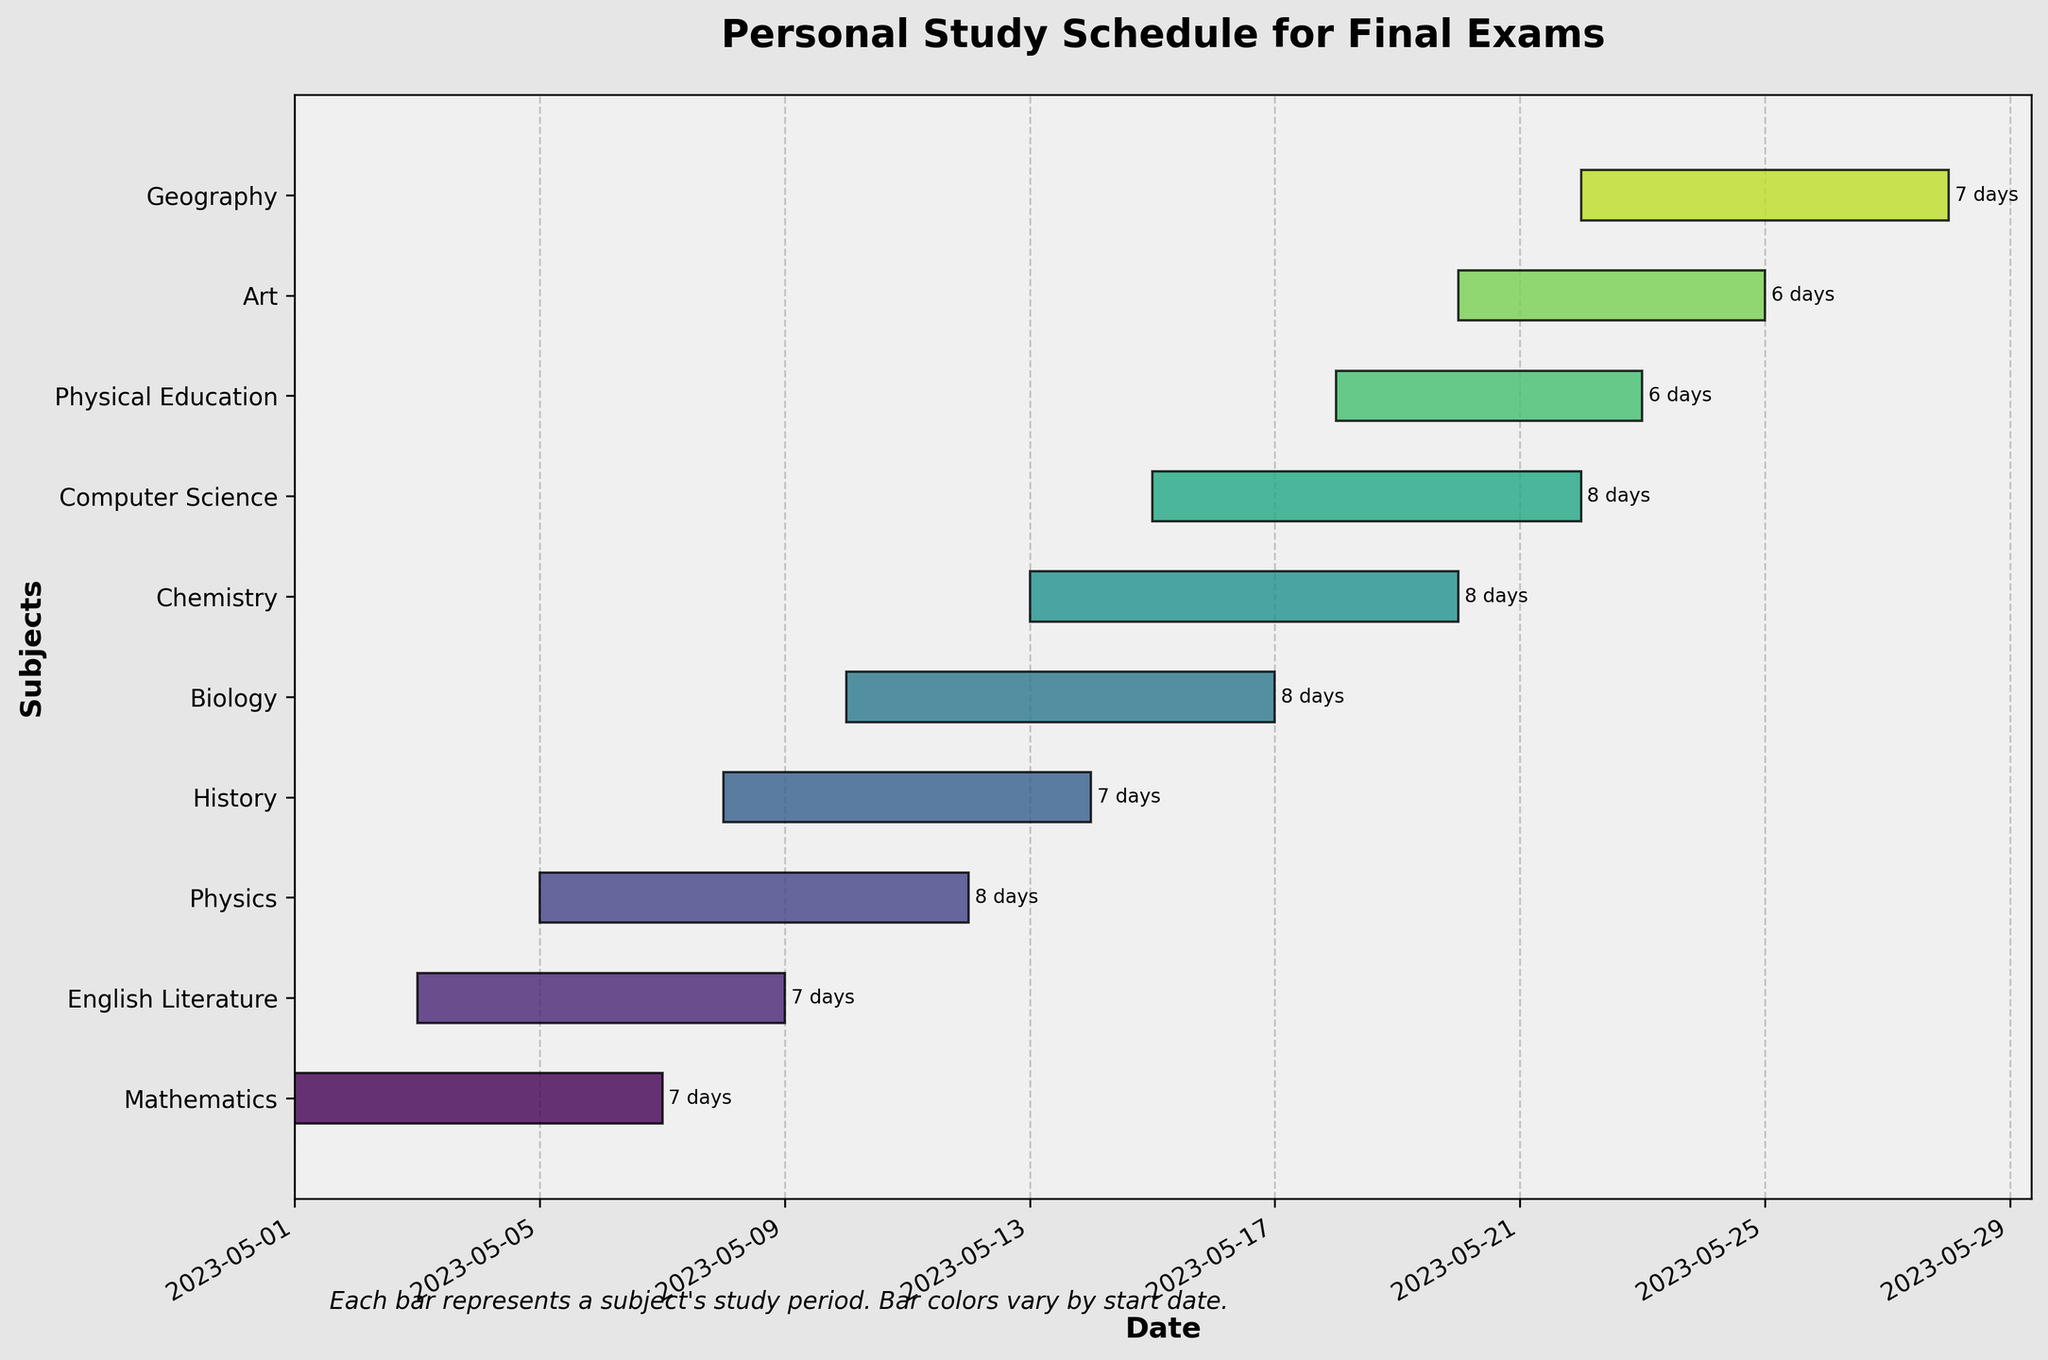What's the title of the Gantt chart? The title of the Gantt chart is usually located at the top center of the figure. It indicates the subject matter of the chart.
Answer: Personal Study Schedule for Final Exams Which subject has the longest study duration? Look at the length of the bars. The subject with the longest bar has the longest study duration. Also, the duration in days is labeled at the end of each bar.
Answer: Physics When does the study period for Biology start and end? Locate the "Biology" bar. The left end of the bar marks the start date and the right end marks the end date. These dates are also listed in the table below.
Answer: Starts on 2023-05-10 and ends on 2023-05-17 How many subjects have a study duration of 7 days? Check the duration labels at the end of each bar. Count the number of bars labeled with "7 days".
Answer: 4 subjects Which subject's study period overlaps with Chemistry? Identify the start and end dates on the Chemistry bar (2023-05-13 to 2023-05-20). Check other bars that have overlapping dates within this range.
Answer: Biology and Computer Science How many days is the gap between the start of the Mathematics study period and the end of the Art study period? Find the start date of Mathematics (2023-05-01) and the end date of Art (2023-05-25). Calculate the difference in days between these two dates.
Answer: 24 days Which two subjects start their study periods on the same day? Look for bars that begin on the same date. These start dates should align vertically.
Answer: Art and Geography Which subject has the shortest study duration? Compare the duration labels at the end of each bar to find the shortest one.
Answer: Physical Education and Art What is the total study period duration for History and English Literature combined? Find the duration of History (7 days) and English Literature (7 days). Add these durations together.
Answer: 14 days 